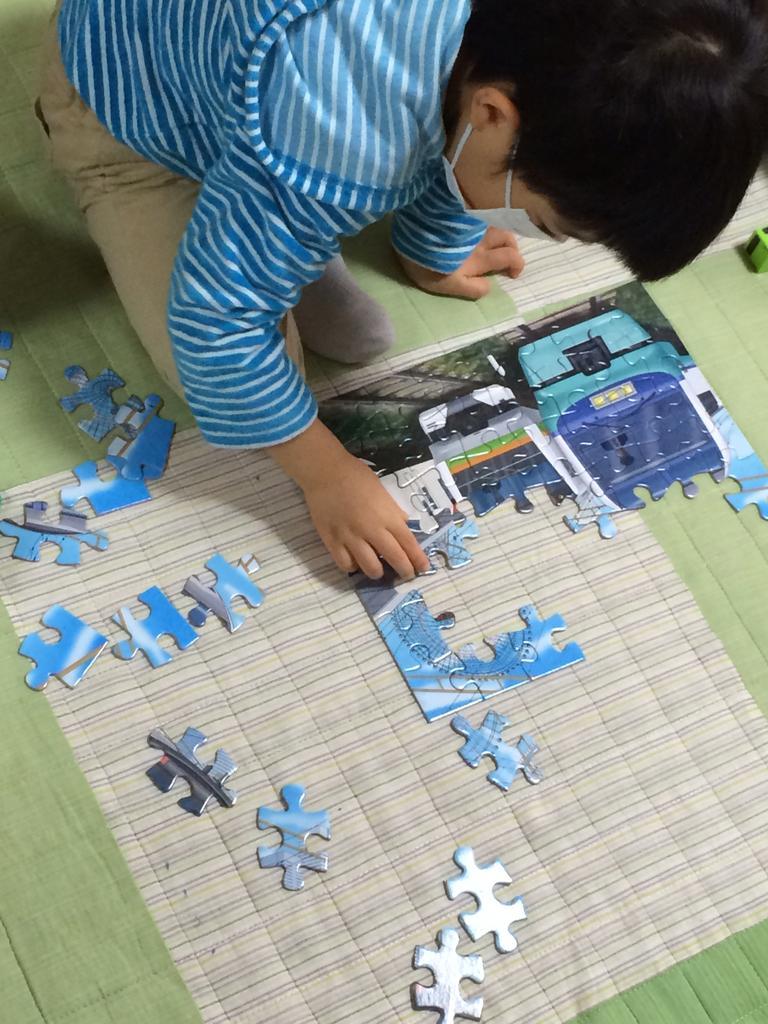Please provide a concise description of this image. In the picture we can see a kid wearing blue color T-shirt, brown color pant sitting on floor playing with puzzle which is on floor. 